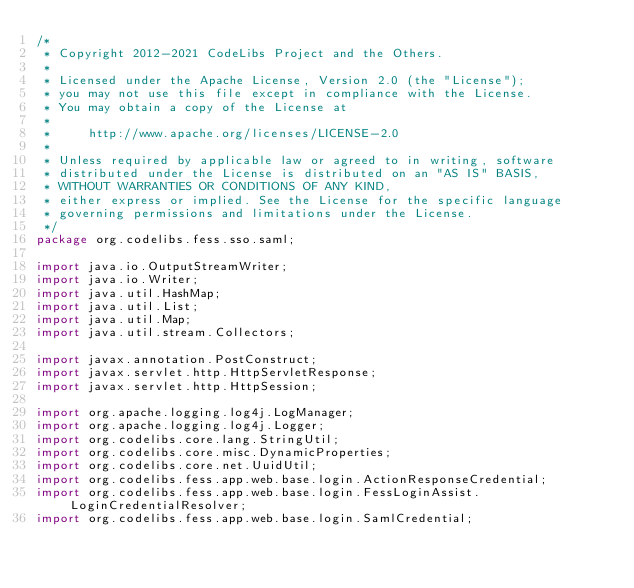Convert code to text. <code><loc_0><loc_0><loc_500><loc_500><_Java_>/*
 * Copyright 2012-2021 CodeLibs Project and the Others.
 *
 * Licensed under the Apache License, Version 2.0 (the "License");
 * you may not use this file except in compliance with the License.
 * You may obtain a copy of the License at
 *
 *     http://www.apache.org/licenses/LICENSE-2.0
 *
 * Unless required by applicable law or agreed to in writing, software
 * distributed under the License is distributed on an "AS IS" BASIS,
 * WITHOUT WARRANTIES OR CONDITIONS OF ANY KIND,
 * either express or implied. See the License for the specific language
 * governing permissions and limitations under the License.
 */
package org.codelibs.fess.sso.saml;

import java.io.OutputStreamWriter;
import java.io.Writer;
import java.util.HashMap;
import java.util.List;
import java.util.Map;
import java.util.stream.Collectors;

import javax.annotation.PostConstruct;
import javax.servlet.http.HttpServletResponse;
import javax.servlet.http.HttpSession;

import org.apache.logging.log4j.LogManager;
import org.apache.logging.log4j.Logger;
import org.codelibs.core.lang.StringUtil;
import org.codelibs.core.misc.DynamicProperties;
import org.codelibs.core.net.UuidUtil;
import org.codelibs.fess.app.web.base.login.ActionResponseCredential;
import org.codelibs.fess.app.web.base.login.FessLoginAssist.LoginCredentialResolver;
import org.codelibs.fess.app.web.base.login.SamlCredential;</code> 